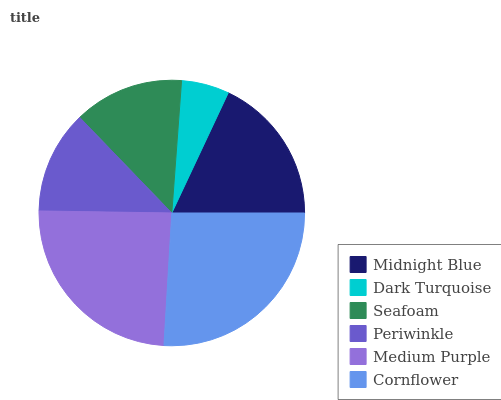Is Dark Turquoise the minimum?
Answer yes or no. Yes. Is Cornflower the maximum?
Answer yes or no. Yes. Is Seafoam the minimum?
Answer yes or no. No. Is Seafoam the maximum?
Answer yes or no. No. Is Seafoam greater than Dark Turquoise?
Answer yes or no. Yes. Is Dark Turquoise less than Seafoam?
Answer yes or no. Yes. Is Dark Turquoise greater than Seafoam?
Answer yes or no. No. Is Seafoam less than Dark Turquoise?
Answer yes or no. No. Is Midnight Blue the high median?
Answer yes or no. Yes. Is Seafoam the low median?
Answer yes or no. Yes. Is Medium Purple the high median?
Answer yes or no. No. Is Midnight Blue the low median?
Answer yes or no. No. 